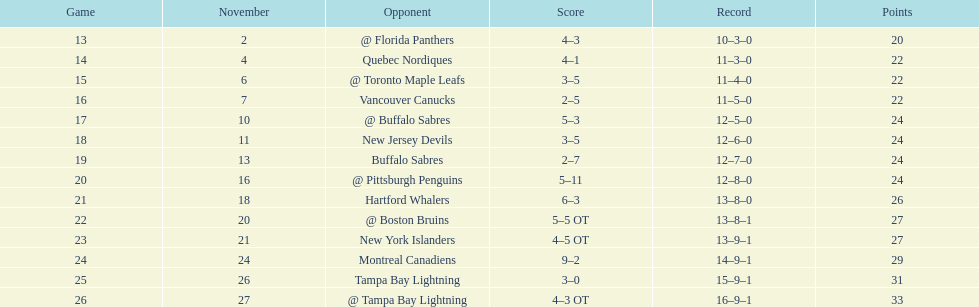The 1993-1994 flyers missed the playoffs again. how many consecutive seasons up until 93-94 did the flyers miss the playoffs? 5. 